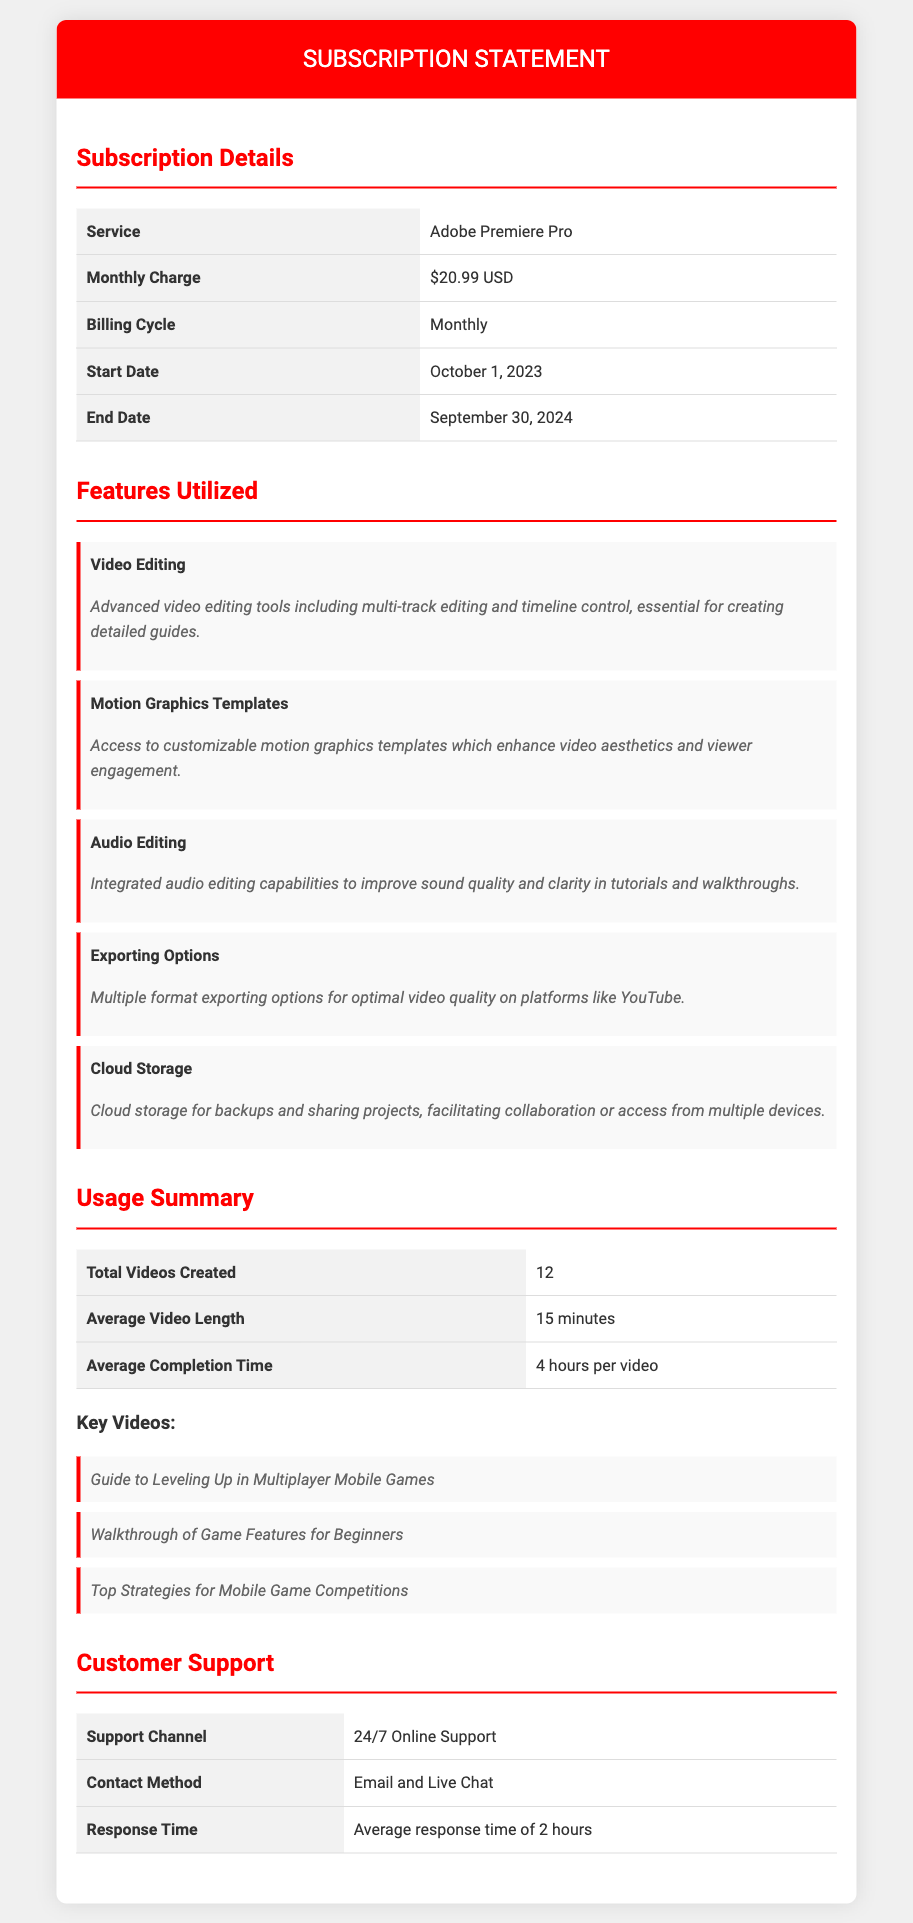what is the monthly charge for Adobe Premiere Pro? The document states the monthly charge for Adobe Premiere Pro is $20.99 USD.
Answer: $20.99 USD when does the subscription start? The subscription start date mentioned in the document is October 1, 2023.
Answer: October 1, 2023 how many total videos were created? The document lists that 12 videos were created under the usage summary section.
Answer: 12 what is one feature utilized for content creation? The document mentions several features, one of them being "Video Editing".
Answer: Video Editing what is the average completion time per video? The average completion time per video as stated in the document is 4 hours per video.
Answer: 4 hours per video what type of customer support is available? The document specifies that there is 24/7 Online Support available for customers.
Answer: 24/7 Online Support which feature allows for project sharing? The document notes that "Cloud Storage" facilitates backups and sharing projects.
Answer: Cloud Storage how many key videos are listed in the document? The document lists three key videos in the usage summary.
Answer: 3 what is the average video length? The average video length mentioned in the document is 15 minutes.
Answer: 15 minutes 